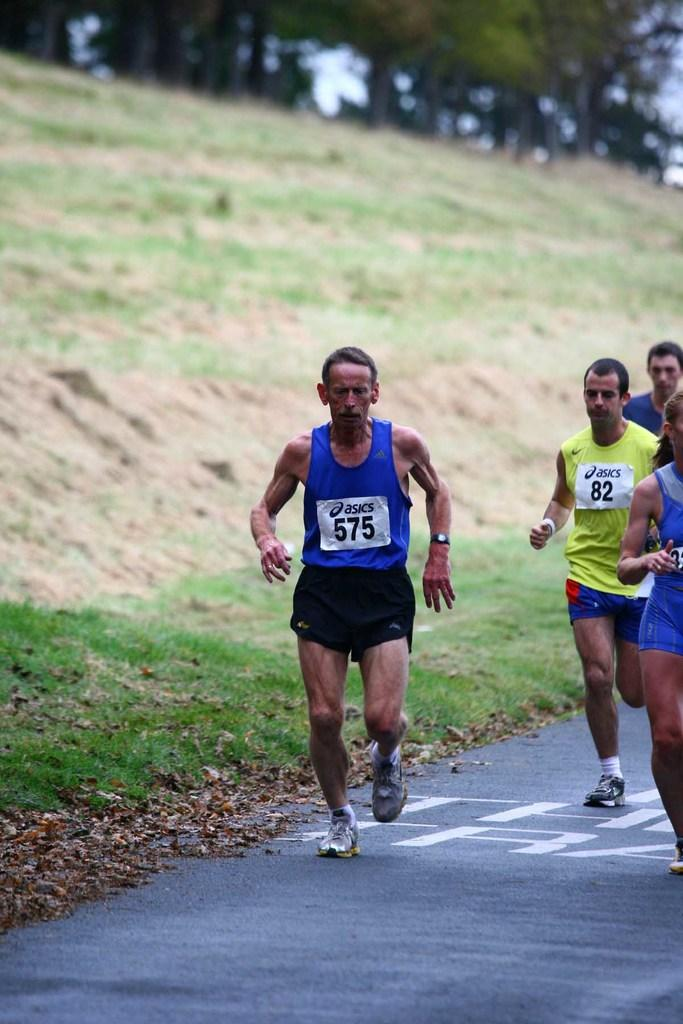What are the people in the image doing? The people in the image are running. What type of terrain can be seen in the image? There is grass visible in the image. What other natural elements can be seen in the image? There are trees in the image. What is visible in the background of the image? The sky is visible in the image. What type of gate can be seen in the image? There is no gate present in the image. What emotion might the people be feeling as they run in the image? It is impossible to determine the emotions of the people in the image based solely on their actions. 